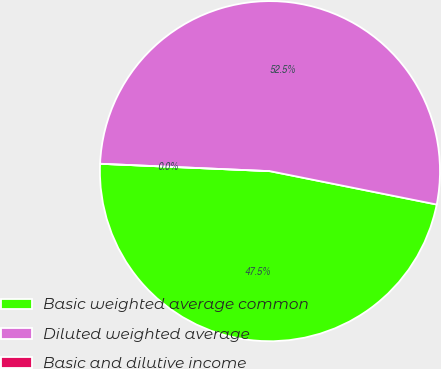<chart> <loc_0><loc_0><loc_500><loc_500><pie_chart><fcel>Basic weighted average common<fcel>Diluted weighted average<fcel>Basic and dilutive income<nl><fcel>47.55%<fcel>52.45%<fcel>0.0%<nl></chart> 